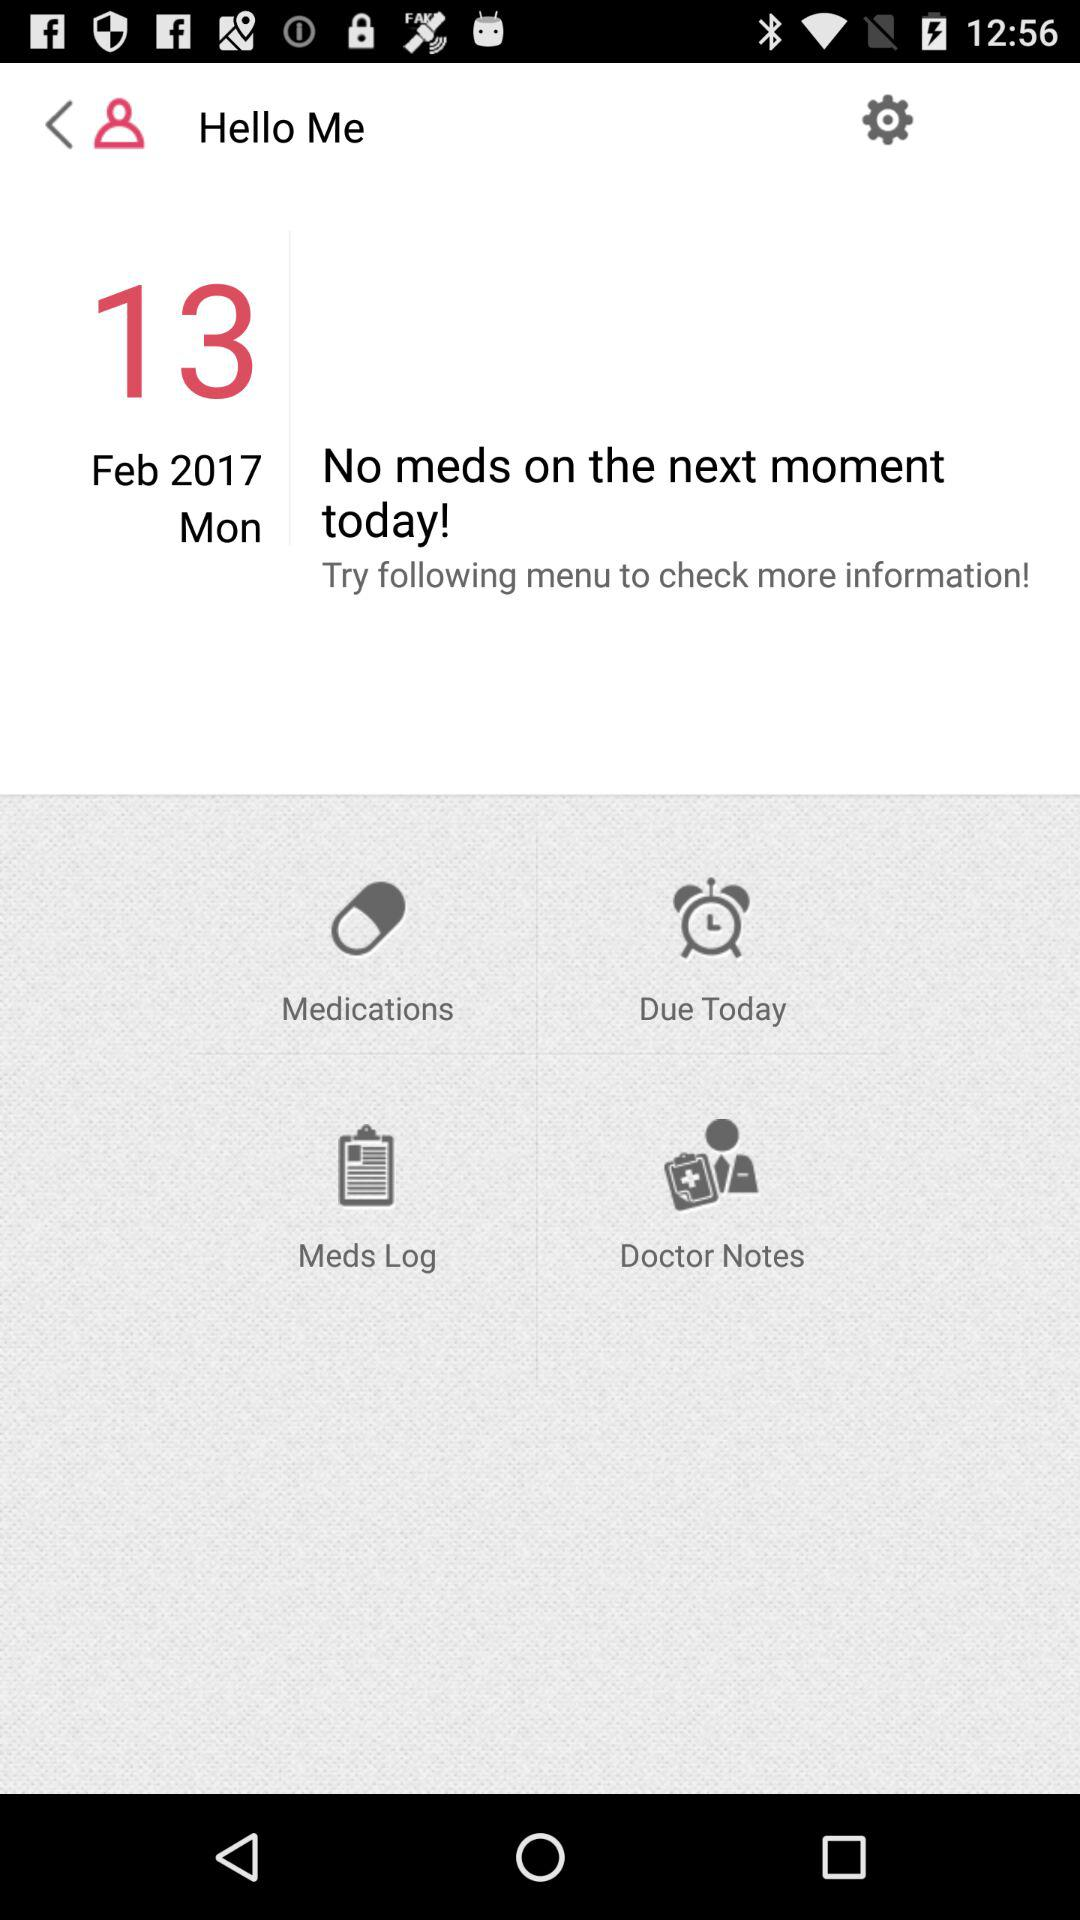When was the last doctor's note received?
When the provided information is insufficient, respond with <no answer>. <no answer> 